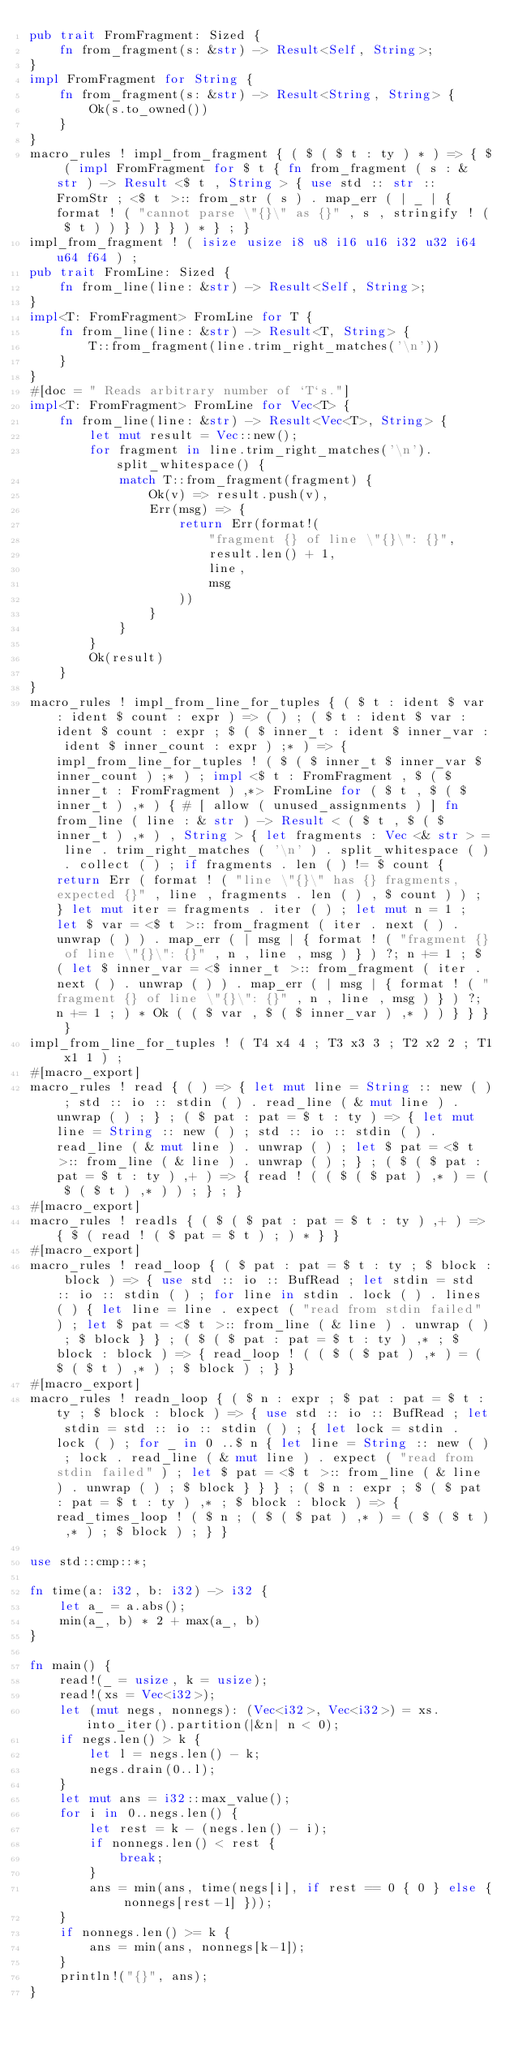Convert code to text. <code><loc_0><loc_0><loc_500><loc_500><_Rust_>pub trait FromFragment: Sized {
    fn from_fragment(s: &str) -> Result<Self, String>;
}
impl FromFragment for String {
    fn from_fragment(s: &str) -> Result<String, String> {
        Ok(s.to_owned())
    }
}
macro_rules ! impl_from_fragment { ( $ ( $ t : ty ) * ) => { $ ( impl FromFragment for $ t { fn from_fragment ( s : & str ) -> Result <$ t , String > { use std :: str :: FromStr ; <$ t >:: from_str ( s ) . map_err ( | _ | { format ! ( "cannot parse \"{}\" as {}" , s , stringify ! ( $ t ) ) } ) } } ) * } ; }
impl_from_fragment ! ( isize usize i8 u8 i16 u16 i32 u32 i64 u64 f64 ) ;
pub trait FromLine: Sized {
    fn from_line(line: &str) -> Result<Self, String>;
}
impl<T: FromFragment> FromLine for T {
    fn from_line(line: &str) -> Result<T, String> {
        T::from_fragment(line.trim_right_matches('\n'))
    }
}
#[doc = " Reads arbitrary number of `T`s."]
impl<T: FromFragment> FromLine for Vec<T> {
    fn from_line(line: &str) -> Result<Vec<T>, String> {
        let mut result = Vec::new();
        for fragment in line.trim_right_matches('\n').split_whitespace() {
            match T::from_fragment(fragment) {
                Ok(v) => result.push(v),
                Err(msg) => {
                    return Err(format!(
                        "fragment {} of line \"{}\": {}",
                        result.len() + 1,
                        line,
                        msg
                    ))
                }
            }
        }
        Ok(result)
    }
}
macro_rules ! impl_from_line_for_tuples { ( $ t : ident $ var : ident $ count : expr ) => ( ) ; ( $ t : ident $ var : ident $ count : expr ; $ ( $ inner_t : ident $ inner_var : ident $ inner_count : expr ) ;* ) => { impl_from_line_for_tuples ! ( $ ( $ inner_t $ inner_var $ inner_count ) ;* ) ; impl <$ t : FromFragment , $ ( $ inner_t : FromFragment ) ,*> FromLine for ( $ t , $ ( $ inner_t ) ,* ) { # [ allow ( unused_assignments ) ] fn from_line ( line : & str ) -> Result < ( $ t , $ ( $ inner_t ) ,* ) , String > { let fragments : Vec <& str > = line . trim_right_matches ( '\n' ) . split_whitespace ( ) . collect ( ) ; if fragments . len ( ) != $ count { return Err ( format ! ( "line \"{}\" has {} fragments, expected {}" , line , fragments . len ( ) , $ count ) ) ; } let mut iter = fragments . iter ( ) ; let mut n = 1 ; let $ var = <$ t >:: from_fragment ( iter . next ( ) . unwrap ( ) ) . map_err ( | msg | { format ! ( "fragment {} of line \"{}\": {}" , n , line , msg ) } ) ?; n += 1 ; $ ( let $ inner_var = <$ inner_t >:: from_fragment ( iter . next ( ) . unwrap ( ) ) . map_err ( | msg | { format ! ( "fragment {} of line \"{}\": {}" , n , line , msg ) } ) ?; n += 1 ; ) * Ok ( ( $ var , $ ( $ inner_var ) ,* ) ) } } } }
impl_from_line_for_tuples ! ( T4 x4 4 ; T3 x3 3 ; T2 x2 2 ; T1 x1 1 ) ;
#[macro_export]
macro_rules ! read { ( ) => { let mut line = String :: new ( ) ; std :: io :: stdin ( ) . read_line ( & mut line ) . unwrap ( ) ; } ; ( $ pat : pat = $ t : ty ) => { let mut line = String :: new ( ) ; std :: io :: stdin ( ) . read_line ( & mut line ) . unwrap ( ) ; let $ pat = <$ t >:: from_line ( & line ) . unwrap ( ) ; } ; ( $ ( $ pat : pat = $ t : ty ) ,+ ) => { read ! ( ( $ ( $ pat ) ,* ) = ( $ ( $ t ) ,* ) ) ; } ; }
#[macro_export]
macro_rules ! readls { ( $ ( $ pat : pat = $ t : ty ) ,+ ) => { $ ( read ! ( $ pat = $ t ) ; ) * } }
#[macro_export]
macro_rules ! read_loop { ( $ pat : pat = $ t : ty ; $ block : block ) => { use std :: io :: BufRead ; let stdin = std :: io :: stdin ( ) ; for line in stdin . lock ( ) . lines ( ) { let line = line . expect ( "read from stdin failed" ) ; let $ pat = <$ t >:: from_line ( & line ) . unwrap ( ) ; $ block } } ; ( $ ( $ pat : pat = $ t : ty ) ,* ; $ block : block ) => { read_loop ! ( ( $ ( $ pat ) ,* ) = ( $ ( $ t ) ,* ) ; $ block ) ; } }
#[macro_export]
macro_rules ! readn_loop { ( $ n : expr ; $ pat : pat = $ t : ty ; $ block : block ) => { use std :: io :: BufRead ; let stdin = std :: io :: stdin ( ) ; { let lock = stdin . lock ( ) ; for _ in 0 ..$ n { let line = String :: new ( ) ; lock . read_line ( & mut line ) . expect ( "read from stdin failed" ) ; let $ pat = <$ t >:: from_line ( & line ) . unwrap ( ) ; $ block } } } ; ( $ n : expr ; $ ( $ pat : pat = $ t : ty ) ,* ; $ block : block ) => { read_times_loop ! ( $ n ; ( $ ( $ pat ) ,* ) = ( $ ( $ t ) ,* ) ; $ block ) ; } }

use std::cmp::*;

fn time(a: i32, b: i32) -> i32 {
    let a_ = a.abs();
    min(a_, b) * 2 + max(a_, b)
}

fn main() {
    read!(_ = usize, k = usize);
    read!(xs = Vec<i32>);
    let (mut negs, nonnegs): (Vec<i32>, Vec<i32>) = xs.into_iter().partition(|&n| n < 0);
    if negs.len() > k {
        let l = negs.len() - k;
        negs.drain(0..l);
    }
    let mut ans = i32::max_value();
    for i in 0..negs.len() {
        let rest = k - (negs.len() - i);
        if nonnegs.len() < rest {
            break;
        }
        ans = min(ans, time(negs[i], if rest == 0 { 0 } else { nonnegs[rest-1] }));
    }
    if nonnegs.len() >= k {
        ans = min(ans, nonnegs[k-1]);
    }
    println!("{}", ans);
}
</code> 